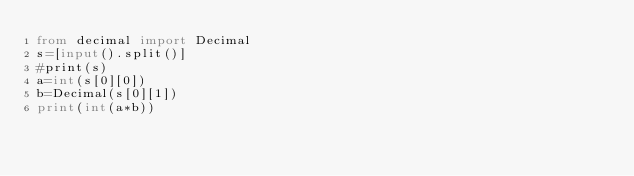Convert code to text. <code><loc_0><loc_0><loc_500><loc_500><_Python_>from decimal import Decimal
s=[input().split()]
#print(s)
a=int(s[0][0])
b=Decimal(s[0][1])
print(int(a*b))</code> 